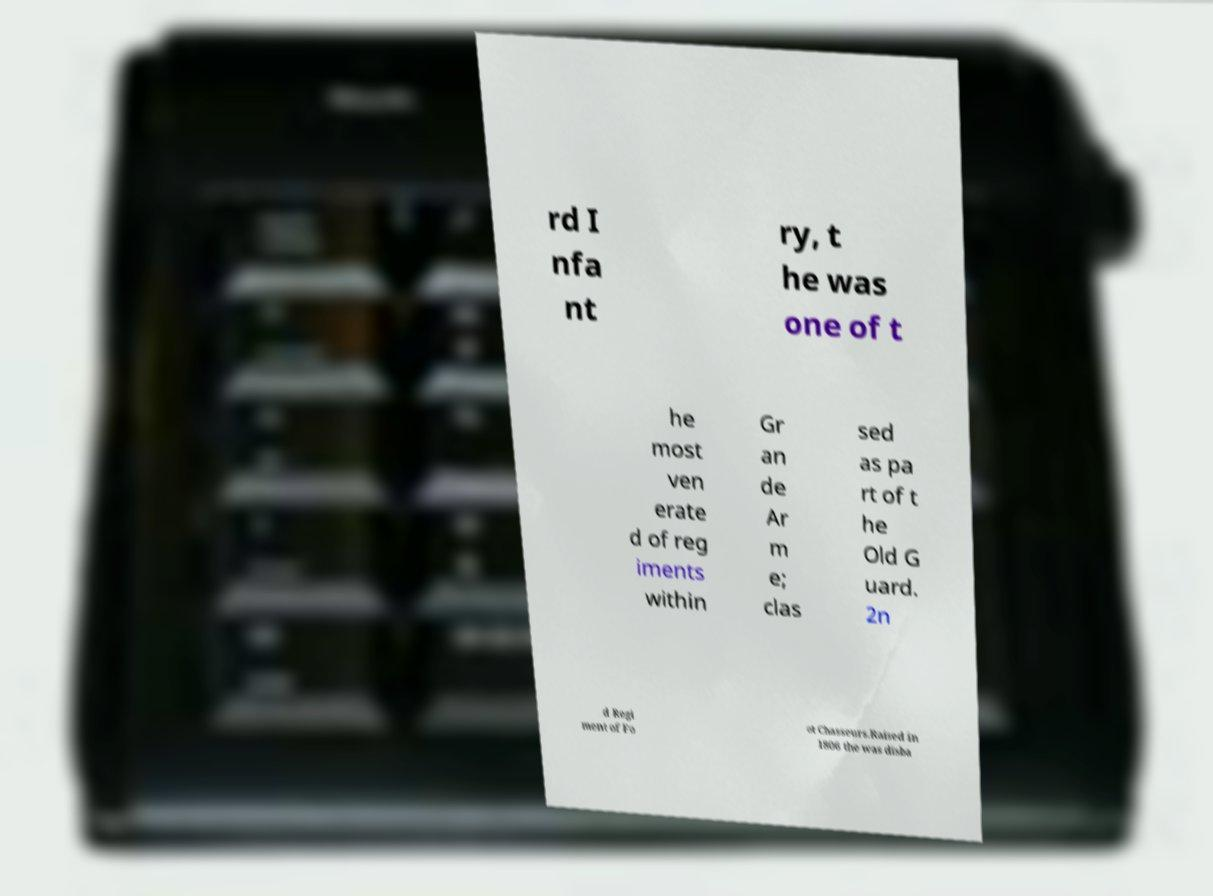Could you assist in decoding the text presented in this image and type it out clearly? rd I nfa nt ry, t he was one of t he most ven erate d of reg iments within Gr an de Ar m e; clas sed as pa rt of t he Old G uard. 2n d Regi ment of Fo ot Chasseurs.Raised in 1806 the was disba 